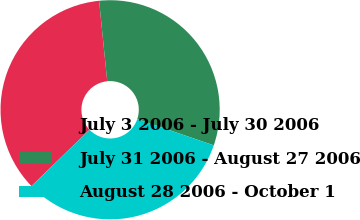Convert chart to OTSL. <chart><loc_0><loc_0><loc_500><loc_500><pie_chart><fcel>July 3 2006 - July 30 2006<fcel>July 31 2006 - August 27 2006<fcel>August 28 2006 - October 1<nl><fcel>35.65%<fcel>31.86%<fcel>32.49%<nl></chart> 